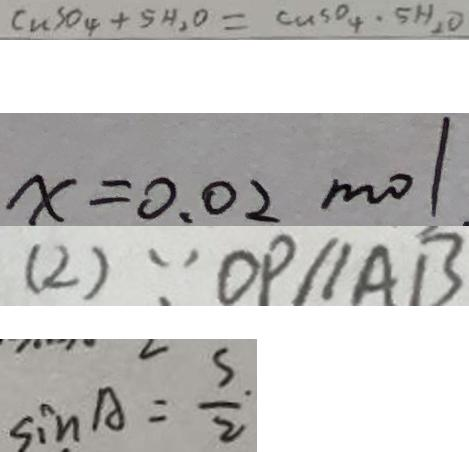<formula> <loc_0><loc_0><loc_500><loc_500>C u S O _ { 4 } + 5 H _ { 2 } O = C u S O _ { 4 } \cdot 5 H _ { 2 } O 
 x = 0 . 0 2 m o l 
 ( 2 ) \because O P / / A B 
 \sin A = \frac { s } { 2 }</formula> 